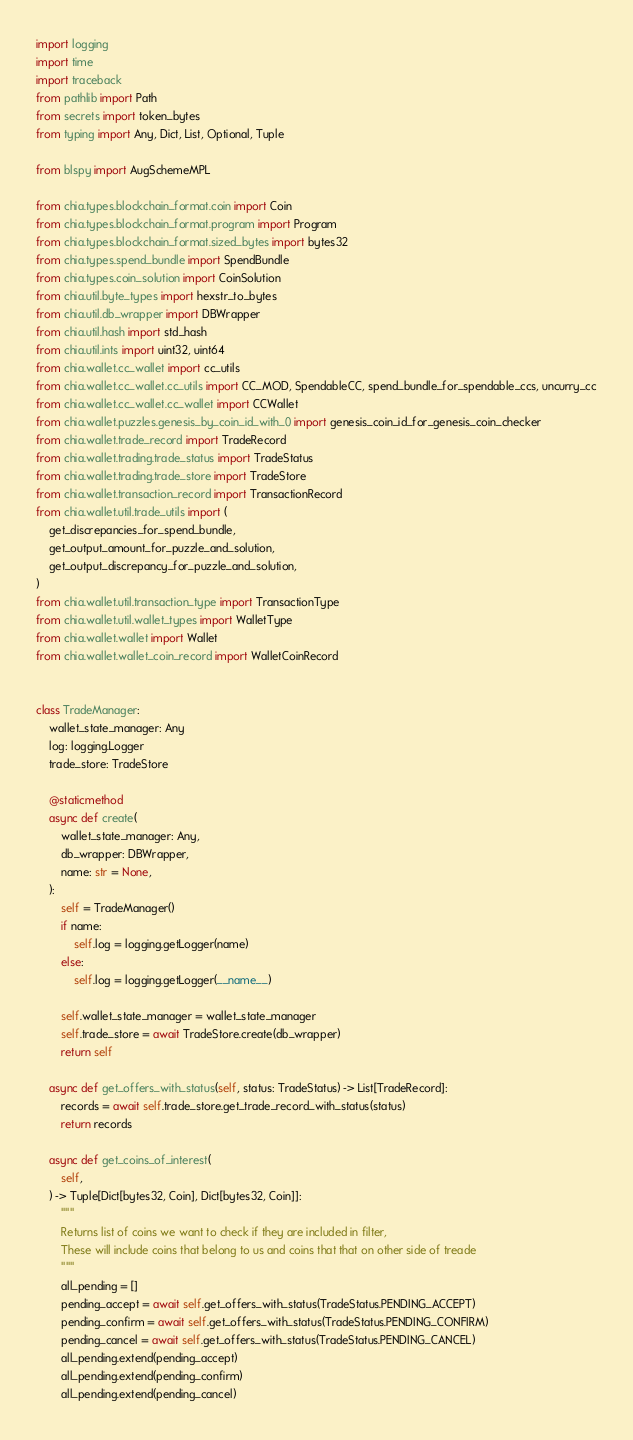<code> <loc_0><loc_0><loc_500><loc_500><_Python_>import logging
import time
import traceback
from pathlib import Path
from secrets import token_bytes
from typing import Any, Dict, List, Optional, Tuple

from blspy import AugSchemeMPL

from chia.types.blockchain_format.coin import Coin
from chia.types.blockchain_format.program import Program
from chia.types.blockchain_format.sized_bytes import bytes32
from chia.types.spend_bundle import SpendBundle
from chia.types.coin_solution import CoinSolution
from chia.util.byte_types import hexstr_to_bytes
from chia.util.db_wrapper import DBWrapper
from chia.util.hash import std_hash
from chia.util.ints import uint32, uint64
from chia.wallet.cc_wallet import cc_utils
from chia.wallet.cc_wallet.cc_utils import CC_MOD, SpendableCC, spend_bundle_for_spendable_ccs, uncurry_cc
from chia.wallet.cc_wallet.cc_wallet import CCWallet
from chia.wallet.puzzles.genesis_by_coin_id_with_0 import genesis_coin_id_for_genesis_coin_checker
from chia.wallet.trade_record import TradeRecord
from chia.wallet.trading.trade_status import TradeStatus
from chia.wallet.trading.trade_store import TradeStore
from chia.wallet.transaction_record import TransactionRecord
from chia.wallet.util.trade_utils import (
    get_discrepancies_for_spend_bundle,
    get_output_amount_for_puzzle_and_solution,
    get_output_discrepancy_for_puzzle_and_solution,
)
from chia.wallet.util.transaction_type import TransactionType
from chia.wallet.util.wallet_types import WalletType
from chia.wallet.wallet import Wallet
from chia.wallet.wallet_coin_record import WalletCoinRecord


class TradeManager:
    wallet_state_manager: Any
    log: logging.Logger
    trade_store: TradeStore

    @staticmethod
    async def create(
        wallet_state_manager: Any,
        db_wrapper: DBWrapper,
        name: str = None,
    ):
        self = TradeManager()
        if name:
            self.log = logging.getLogger(name)
        else:
            self.log = logging.getLogger(__name__)

        self.wallet_state_manager = wallet_state_manager
        self.trade_store = await TradeStore.create(db_wrapper)
        return self

    async def get_offers_with_status(self, status: TradeStatus) -> List[TradeRecord]:
        records = await self.trade_store.get_trade_record_with_status(status)
        return records

    async def get_coins_of_interest(
        self,
    ) -> Tuple[Dict[bytes32, Coin], Dict[bytes32, Coin]]:
        """
        Returns list of coins we want to check if they are included in filter,
        These will include coins that belong to us and coins that that on other side of treade
        """
        all_pending = []
        pending_accept = await self.get_offers_with_status(TradeStatus.PENDING_ACCEPT)
        pending_confirm = await self.get_offers_with_status(TradeStatus.PENDING_CONFIRM)
        pending_cancel = await self.get_offers_with_status(TradeStatus.PENDING_CANCEL)
        all_pending.extend(pending_accept)
        all_pending.extend(pending_confirm)
        all_pending.extend(pending_cancel)</code> 